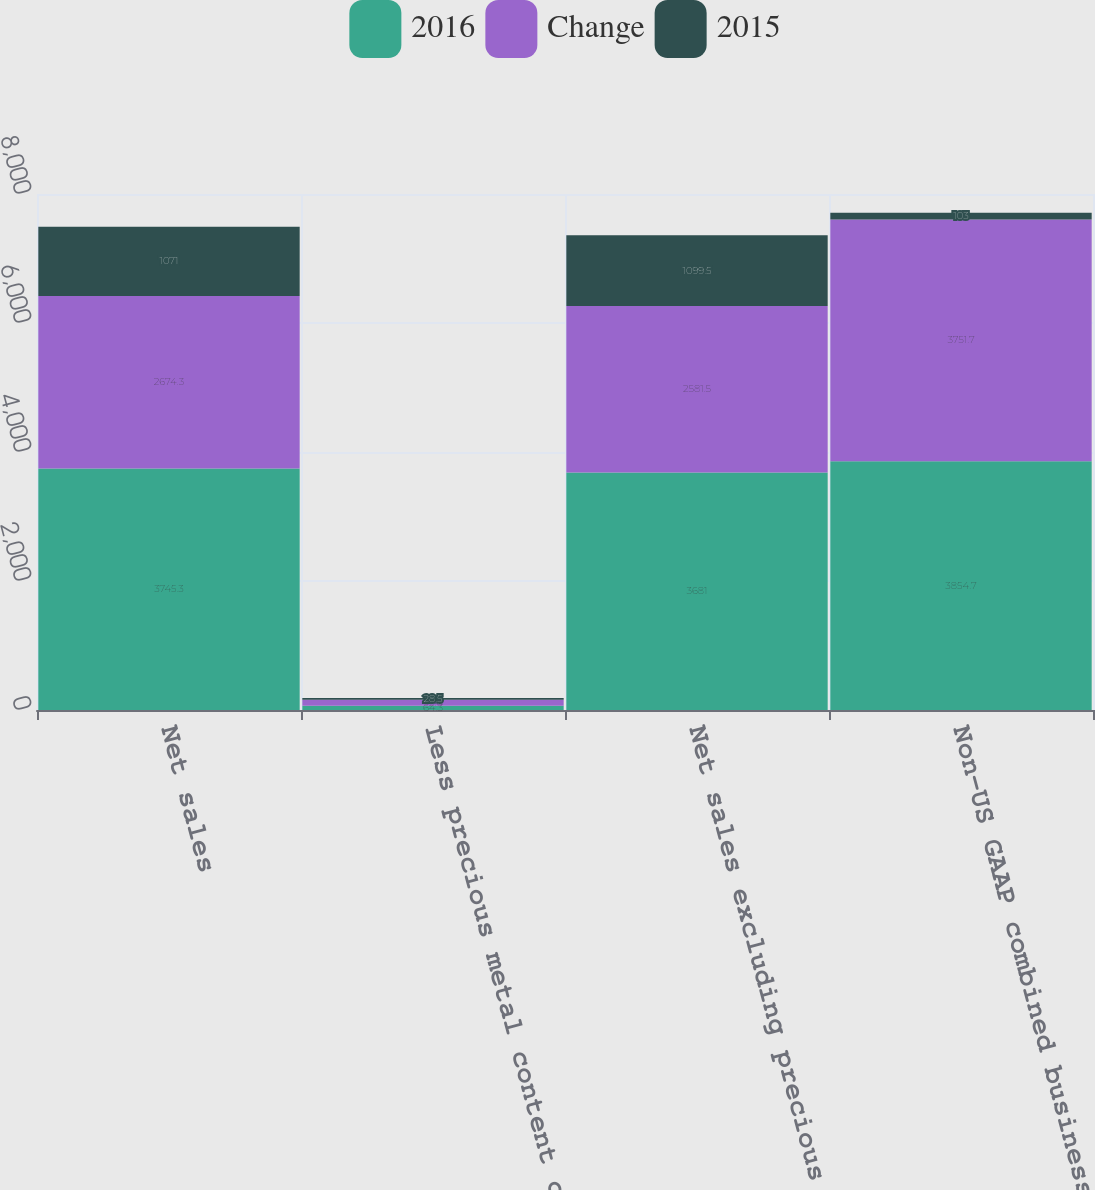<chart> <loc_0><loc_0><loc_500><loc_500><stacked_bar_chart><ecel><fcel>Net sales<fcel>Less precious metal content of<fcel>Net sales excluding precious<fcel>Non-US GAAP combined business<nl><fcel>2016<fcel>3745.3<fcel>64.3<fcel>3681<fcel>3854.7<nl><fcel>Change<fcel>2674.3<fcel>92.8<fcel>2581.5<fcel>3751.7<nl><fcel>2015<fcel>1071<fcel>28.5<fcel>1099.5<fcel>103<nl></chart> 